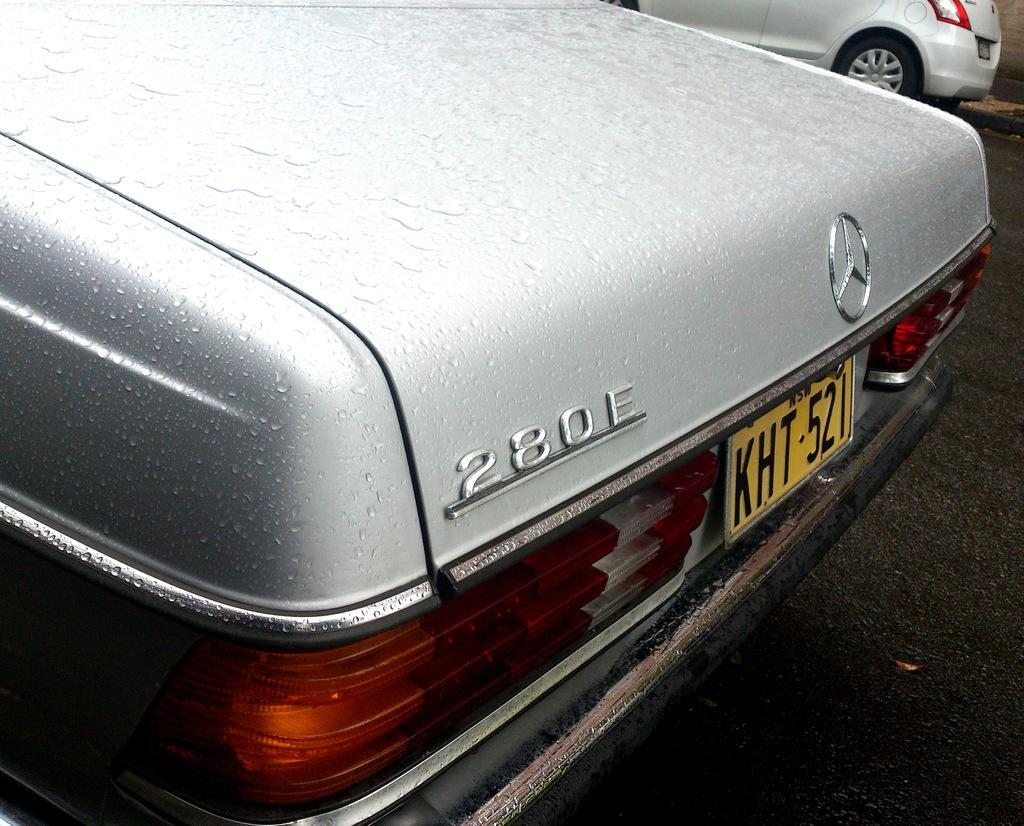What brand of vehicle is in the image? There is a vehicle with a Mercedes Benz logo in the image. Where is the vehicle located? The vehicle is on the road. Is there another vehicle in the image? Yes, there is another vehicle beside it. What type of sponge is being used to clean the vehicle in the image? There is no sponge or cleaning activity depicted in the image. Is the father of the driver visible in the image? There is no information about the driver or any passengers in the image, so it cannot be determined if the father is present. 